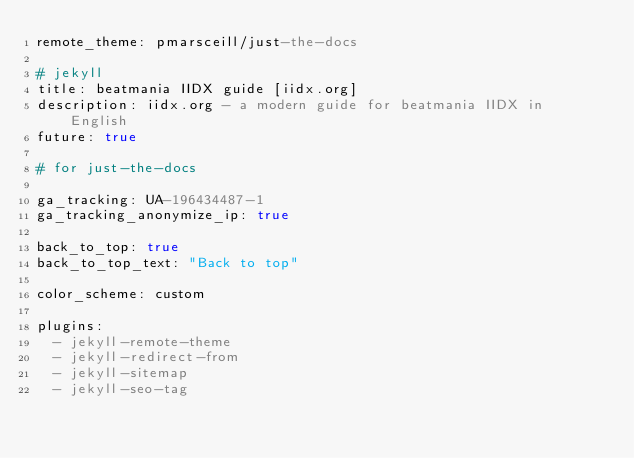<code> <loc_0><loc_0><loc_500><loc_500><_YAML_>remote_theme: pmarsceill/just-the-docs

# jekyll
title: beatmania IIDX guide [iidx.org]
description: iidx.org - a modern guide for beatmania IIDX in English
future: true

# for just-the-docs

ga_tracking: UA-196434487-1
ga_tracking_anonymize_ip: true

back_to_top: true
back_to_top_text: "Back to top"

color_scheme: custom

plugins:
  - jekyll-remote-theme
  - jekyll-redirect-from
  - jekyll-sitemap
  - jekyll-seo-tag</code> 